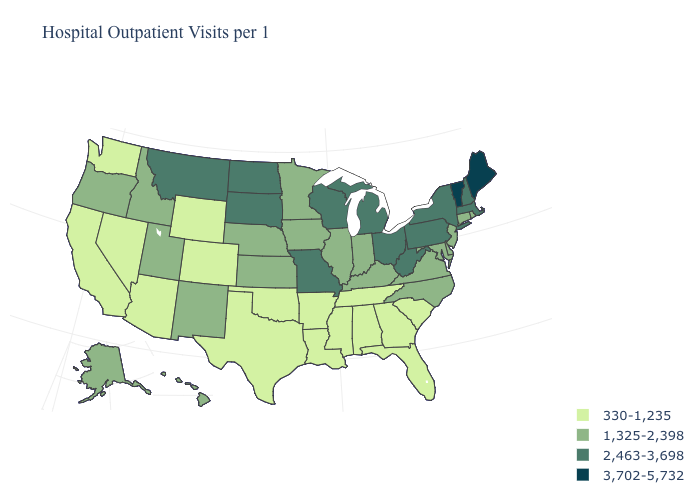Among the states that border Georgia , does North Carolina have the highest value?
Keep it brief. Yes. What is the lowest value in the USA?
Keep it brief. 330-1,235. What is the lowest value in states that border Wisconsin?
Short answer required. 1,325-2,398. Which states hav the highest value in the MidWest?
Concise answer only. Michigan, Missouri, North Dakota, Ohio, South Dakota, Wisconsin. Name the states that have a value in the range 2,463-3,698?
Concise answer only. Massachusetts, Michigan, Missouri, Montana, New Hampshire, New York, North Dakota, Ohio, Pennsylvania, South Dakota, West Virginia, Wisconsin. Among the states that border Wisconsin , does Minnesota have the highest value?
Quick response, please. No. Which states have the lowest value in the USA?
Give a very brief answer. Alabama, Arizona, Arkansas, California, Colorado, Florida, Georgia, Louisiana, Mississippi, Nevada, Oklahoma, South Carolina, Tennessee, Texas, Washington, Wyoming. Does the first symbol in the legend represent the smallest category?
Quick response, please. Yes. Among the states that border Nevada , does Arizona have the lowest value?
Concise answer only. Yes. What is the value of Oregon?
Answer briefly. 1,325-2,398. What is the lowest value in states that border Maryland?
Give a very brief answer. 1,325-2,398. Does the first symbol in the legend represent the smallest category?
Quick response, please. Yes. Does West Virginia have the lowest value in the USA?
Be succinct. No. Does Georgia have the highest value in the USA?
Quick response, please. No. How many symbols are there in the legend?
Give a very brief answer. 4. 